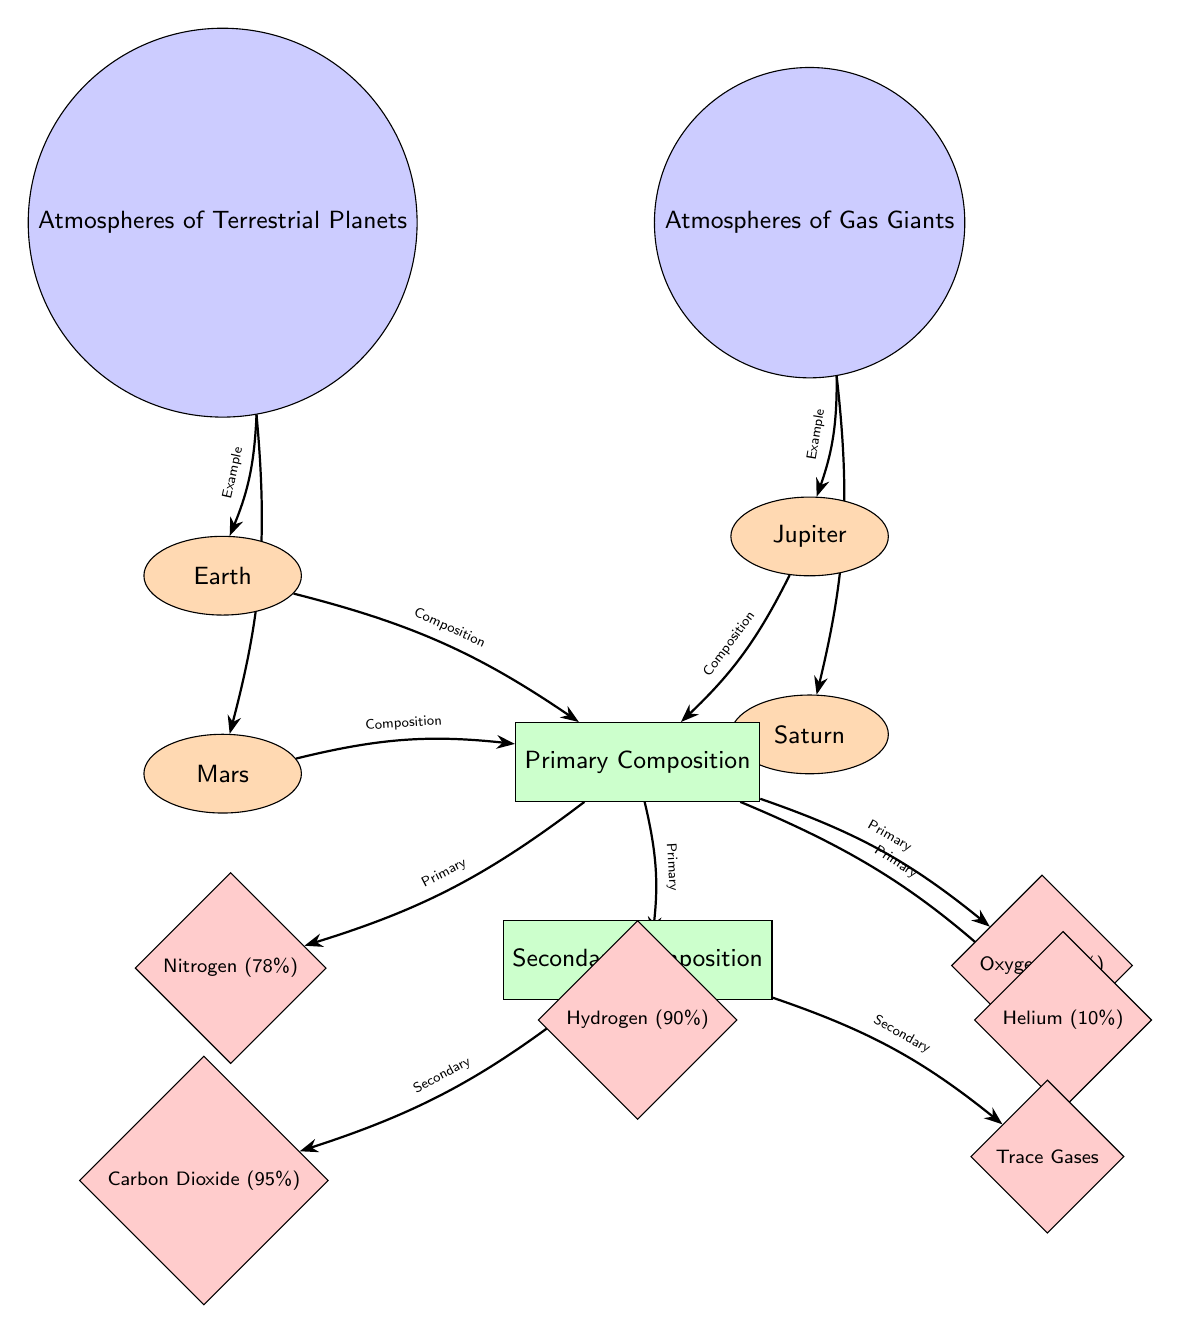What are the two main categories of planetary atmospheres? The diagram presents two distinct categories: "Atmospheres of Terrestrial Planets" and "Atmospheres of Gas Giants" located at the top of the diagram.
Answer: Terrestrial Planets, Gas Giants How many examples of terrestrial planets are listed? In the diagram, there are two planetary nodes listed under "Atmospheres of Terrestrial Planets": Earth and Mars. This makes a total of two examples.
Answer: 2 What is the primary composition of Earth's atmosphere? The diagram indicates that Earth's atmosphere has a primary composition that includes Nitrogen (78%) and Oxygen (21%). The question specifies "primary," so we focus on these given percentages under the "Primary Composition" section.
Answer: Nitrogen, Oxygen Which gas is present in the highest percentage in the atmosphere of Mars? The diagram shows that the secondary composition of Mars's atmosphere mainly consists of Carbon Dioxide (95%), as indicated under the "Secondary Composition" node associated with Mars.
Answer: Carbon Dioxide What is the total primary composition of Jupiter's atmosphere? The diagram lists Jupiter's primary atmospheric components as Hydrogen (90%) and Helium (10%). Adding these percentages gives a total of 100% for its primary atmospheric composition.
Answer: Hydrogen, Helium What distinguishes gas giants from terrestrial planets regarding atmospheric composition? Gas giants, as shown, primarily consist of Hydrogen and Helium, while terrestrial planets mainly have Nitrogen and Oxygen. This distinction shows a fundamental difference in atmospheric composition between the two groups.
Answer: Hydrogen, Helium vs. Nitrogen, Oxygen Which two components make up the primary composition of Saturn's atmosphere? The diagram outlines that Saturn's atmosphere also consists primarily of Hydrogen (90%) and Helium (10%), similar to Jupiter. Thus, those are the components we consider for this question.
Answer: Hydrogen, Helium What type of gases is categorized under "Trace Gases"? The diagram specifies "Trace Gases" as a category under the "Secondary Composition" for terrestrial and gas giants but does not detail specific gases. However, it signifies that these are present in minor amounts.
Answer: Trace Gases 